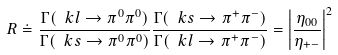Convert formula to latex. <formula><loc_0><loc_0><loc_500><loc_500>R \doteq \frac { \Gamma ( \ k l \rightarrow \pi ^ { 0 } \pi ^ { 0 } ) } { \Gamma ( \ k s \rightarrow \pi ^ { 0 } \pi ^ { 0 } ) } \frac { \Gamma ( \ k s \rightarrow \pi ^ { + } \pi ^ { - } ) } { \Gamma ( \ k l \rightarrow \pi ^ { + } \pi ^ { - } ) } = \left | \frac { \eta _ { 0 0 } } { \eta _ { + - } } \right | ^ { 2 }</formula> 